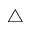<formula> <loc_0><loc_0><loc_500><loc_500>\triangle</formula> 